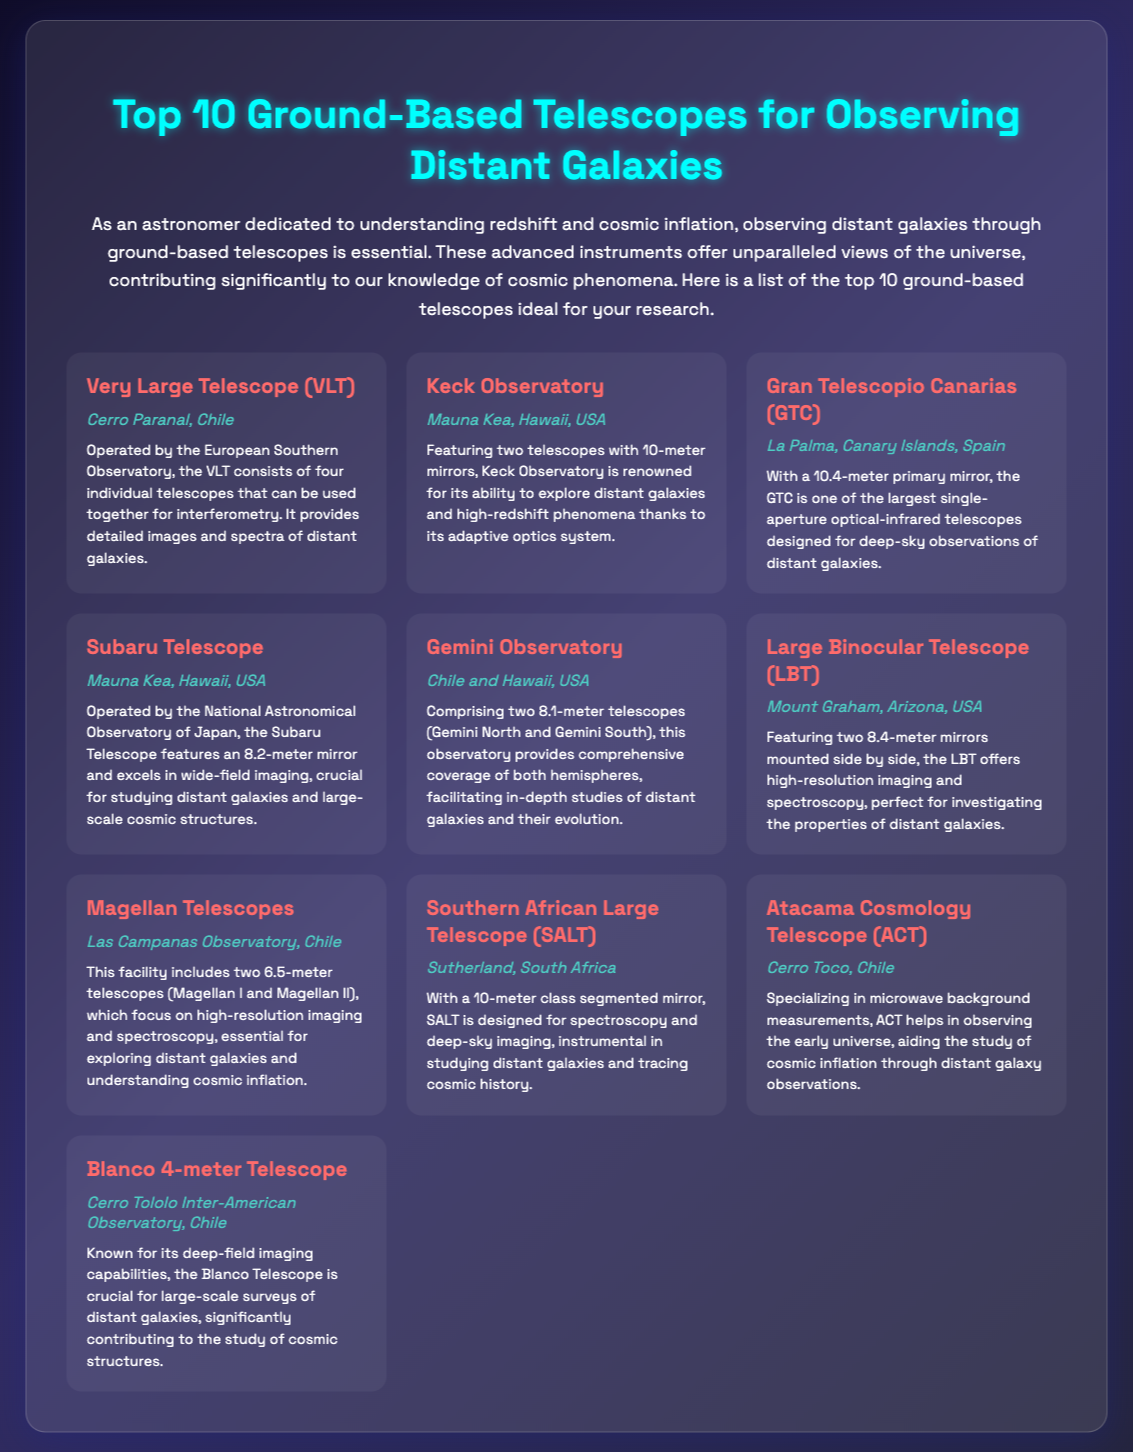what is the name of the telescope located in Chile operated by the European Southern Observatory? The document mentions the Very Large Telescope (VLT) as operated by the European Southern Observatory and located in Cerro Paranal, Chile.
Answer: Very Large Telescope (VLT) how many meters is the primary mirror of the Gran Telescopio Canarias? The document specifies that the Gran Telescopio Canarias (GTC) has a 10.4-meter primary mirror.
Answer: 10.4 meters which telescope features an 8.2-meter mirror and is operated by the National Astronomical Observatory of Japan? According to the document, the Subaru Telescope features an 8.2-meter mirror and is operated by the National Astronomical Observatory of Japan.
Answer: Subaru Telescope what is the unique feature of the Large Binocular Telescope? The document describes the Large Binocular Telescope as featuring two 8.4-meter mirrors mounted side by side, which is its unique characteristic.
Answer: two 8.4-meter mirrors which two observatories provide comprehensive coverage of both hemispheres? The Gemini Observatory comprises two telescopes (Gemini North and Gemini South) that provide comprehensive coverage of both hemispheres.
Answer: Gemini Observatory which telescope specializes in microwave background measurements? The Atacama Cosmology Telescope (ACT) is mentioned in the document as specializing in microwave background measurements.
Answer: Atacama Cosmology Telescope (ACT) how does the Gran Telescopio Canarias contribute to distant galaxy observations? The document states that the Gran Telescopio Canarias is designed for deep-sky observations of distant galaxies due to its large 10.4-meter mirror.
Answer: deep-sky observations what type of imaging is the Blanco 4-meter Telescope known for? The document indicates that the Blanco 4-meter Telescope is known for its deep-field imaging capabilities.
Answer: deep-field imaging how many telescopes are included in the Magellan Telescopes facility? The document mentions that the Magellan Telescopes facility includes two telescopes, Magellan I and Magellan II.
Answer: two telescopes what is the primary purpose of the Southern African Large Telescope (SALT)? The document describes the Southern African Large Telescope (SALT) as designed for spectroscopy and deep-sky imaging.
Answer: spectroscopy and deep-sky imaging 